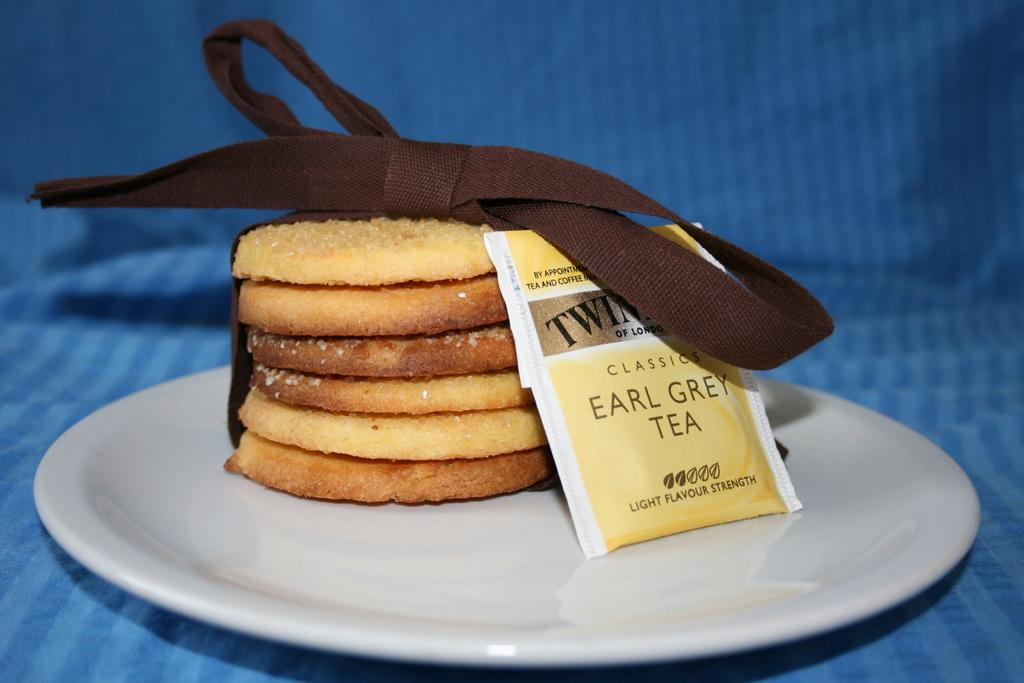What is present on the plate in the image? There are food items on a plate in the image. What else can be seen in the image besides the food items? There are text tags visible in the image. What type of caption can be seen on the men's clothing in the image? There is no mention of men or clothing in the image, so it is not possible to answer that question. 